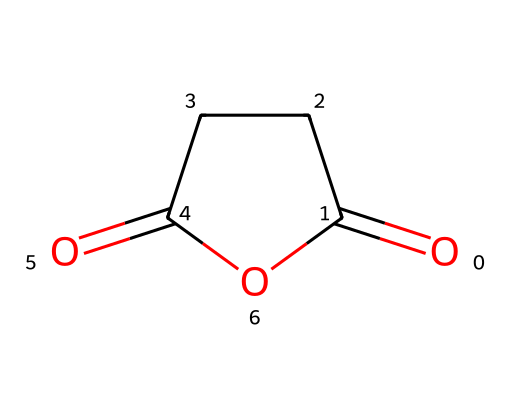What is the molecular formula of succinic anhydride? The molecular structure consists of four carbon atoms (C), four hydrogen atoms (H), and three oxygen atoms (O). Thus, the molecular formula is derived from counting these elements in the structure.
Answer: C4H4O3 How many oxygen atoms are present in succinic anhydride? By examining the SMILES representation, we can identify the distinct oxygen atoms in the structure. There are three oxygen atoms (counting each 'O' in the SMILES).
Answer: 3 Is succinic anhydride a cyclic compound? The presence of the 'C1' in the SMILES notation indicates a ring structure while enclosing atoms. Thus, it can be deduced that succinic anhydride forms a cycle.
Answer: yes What functional groups can be identified in succinic anhydride? Identifying the structure shows two carbonyl (C=O) groups and a cyclic anhydride feature, indicating that it is mostly characterized by an anhydride functional group.
Answer: anhydride How does the structure of succinic anhydride contribute to its biodegradable properties? The anhydride functional group, along with the carbon backbone, makes it more reactive with water and other biological molecules, allowing for breakdown. Thus, this arrangement is key to its biodegradability.
Answer: anhydride structure What type of reaction can succinic anhydride undergo due to its reactivity? Succinic anhydride is known to participate in hydrolysis reactions whereby it can react with water, breaking down into the corresponding acid. This behavior is characteristic of acid anhydrides.
Answer: hydrolysis 